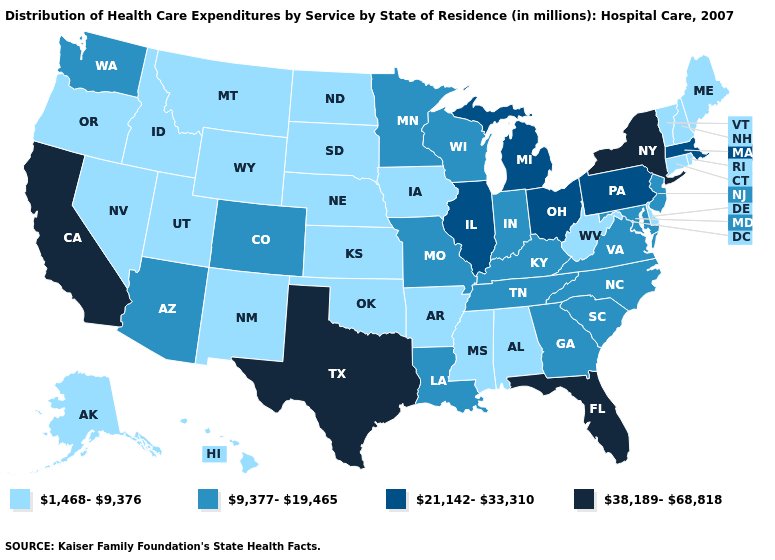What is the lowest value in states that border Pennsylvania?
Give a very brief answer. 1,468-9,376. Which states have the lowest value in the USA?
Short answer required. Alabama, Alaska, Arkansas, Connecticut, Delaware, Hawaii, Idaho, Iowa, Kansas, Maine, Mississippi, Montana, Nebraska, Nevada, New Hampshire, New Mexico, North Dakota, Oklahoma, Oregon, Rhode Island, South Dakota, Utah, Vermont, West Virginia, Wyoming. Name the states that have a value in the range 38,189-68,818?
Keep it brief. California, Florida, New York, Texas. Among the states that border Pennsylvania , which have the highest value?
Keep it brief. New York. Does Arkansas have the lowest value in the USA?
Answer briefly. Yes. What is the value of Wyoming?
Concise answer only. 1,468-9,376. How many symbols are there in the legend?
Give a very brief answer. 4. Which states have the lowest value in the MidWest?
Answer briefly. Iowa, Kansas, Nebraska, North Dakota, South Dakota. What is the value of Wyoming?
Quick response, please. 1,468-9,376. Does Louisiana have the same value as Kentucky?
Quick response, please. Yes. What is the value of Idaho?
Be succinct. 1,468-9,376. Which states have the lowest value in the USA?
Keep it brief. Alabama, Alaska, Arkansas, Connecticut, Delaware, Hawaii, Idaho, Iowa, Kansas, Maine, Mississippi, Montana, Nebraska, Nevada, New Hampshire, New Mexico, North Dakota, Oklahoma, Oregon, Rhode Island, South Dakota, Utah, Vermont, West Virginia, Wyoming. What is the highest value in the Northeast ?
Keep it brief. 38,189-68,818. Among the states that border Texas , which have the lowest value?
Be succinct. Arkansas, New Mexico, Oklahoma. Does Arizona have the lowest value in the West?
Give a very brief answer. No. 